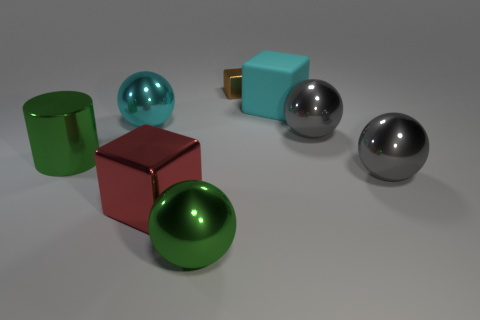Subtract all cyan spheres. How many spheres are left? 3 Add 1 matte objects. How many objects exist? 9 Subtract all gray cubes. How many gray balls are left? 2 Subtract all cyan spheres. How many spheres are left? 3 Subtract all cylinders. How many objects are left? 7 Subtract 1 cylinders. How many cylinders are left? 0 Subtract 0 yellow balls. How many objects are left? 8 Subtract all green spheres. Subtract all red cylinders. How many spheres are left? 3 Subtract all green cubes. Subtract all matte objects. How many objects are left? 7 Add 3 cyan rubber blocks. How many cyan rubber blocks are left? 4 